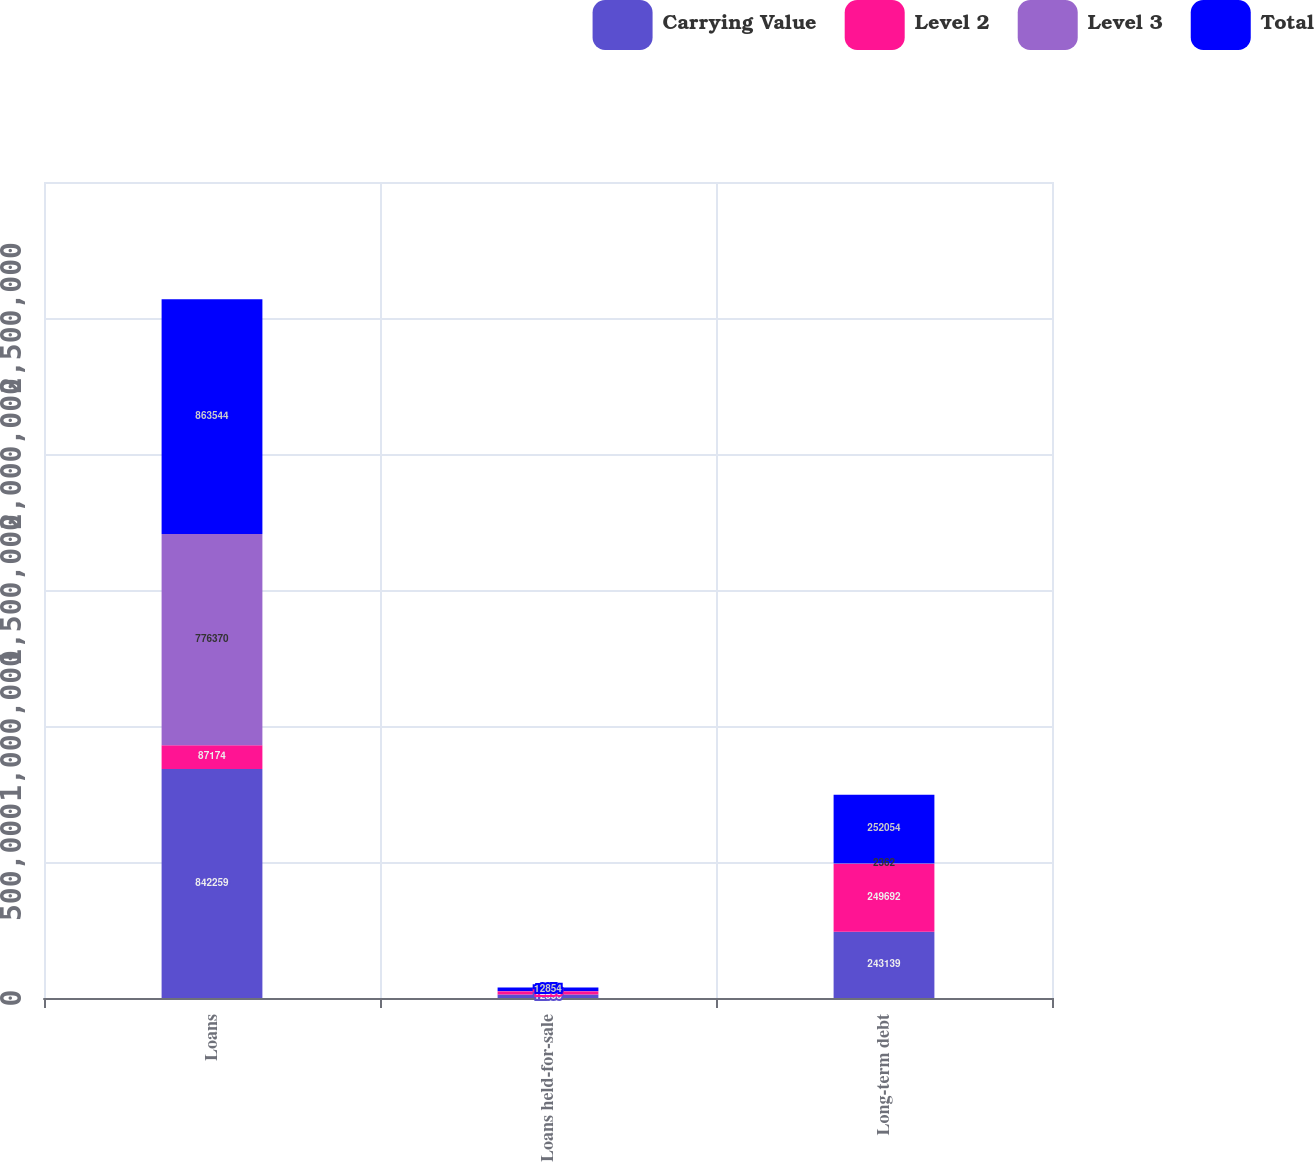Convert chart. <chart><loc_0><loc_0><loc_500><loc_500><stacked_bar_chart><ecel><fcel>Loans<fcel>Loans held-for-sale<fcel>Long-term debt<nl><fcel>Carrying Value<fcel>842259<fcel>12836<fcel>243139<nl><fcel>Level 2<fcel>87174<fcel>12236<fcel>249692<nl><fcel>Level 3<fcel>776370<fcel>618<fcel>2362<nl><fcel>Total<fcel>863544<fcel>12854<fcel>252054<nl></chart> 